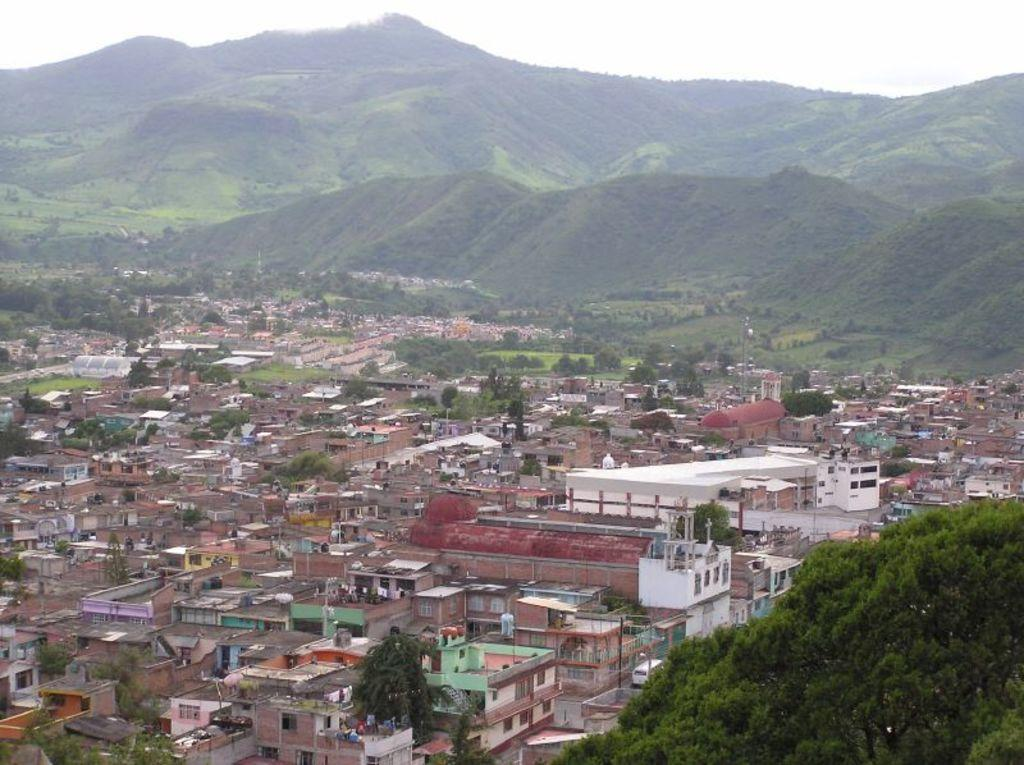What type of vegetation is on the right side of the image? There are trees on the right side of the image. What type of structures are on the left side of the image? There are buildings on the left side of the image. What natural features can be seen in the image? Hills are visible in the image. What is the weight of the thing that is twisting in the image? There is no object in the image that is twisting or has a weight associated with it. 